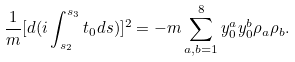Convert formula to latex. <formula><loc_0><loc_0><loc_500><loc_500>\frac { 1 } { m } [ d ( i \int _ { s _ { 2 } } ^ { s _ { 3 } } t _ { 0 } d s ) ] ^ { 2 } = - m \sum _ { a , b = 1 } ^ { 8 } y _ { 0 } ^ { a } y _ { 0 } ^ { b } \rho _ { a } \rho _ { b } .</formula> 